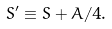<formula> <loc_0><loc_0><loc_500><loc_500>S ^ { \prime } \equiv S + A / 4 .</formula> 